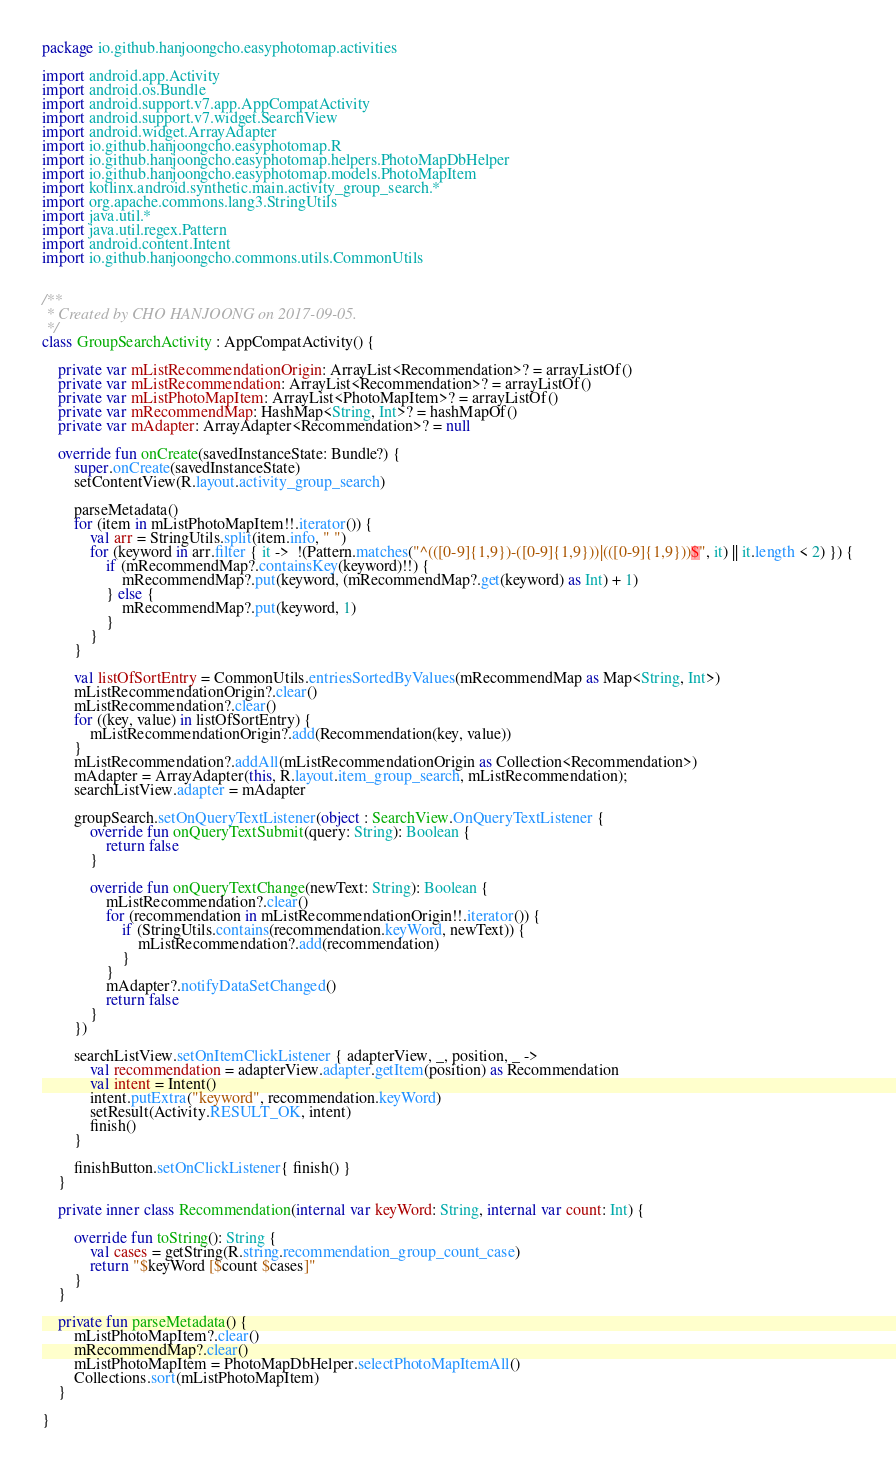<code> <loc_0><loc_0><loc_500><loc_500><_Kotlin_>package io.github.hanjoongcho.easyphotomap.activities

import android.app.Activity
import android.os.Bundle
import android.support.v7.app.AppCompatActivity
import android.support.v7.widget.SearchView
import android.widget.ArrayAdapter
import io.github.hanjoongcho.easyphotomap.R
import io.github.hanjoongcho.easyphotomap.helpers.PhotoMapDbHelper
import io.github.hanjoongcho.easyphotomap.models.PhotoMapItem
import kotlinx.android.synthetic.main.activity_group_search.*
import org.apache.commons.lang3.StringUtils
import java.util.*
import java.util.regex.Pattern
import android.content.Intent
import io.github.hanjoongcho.commons.utils.CommonUtils


/**
 * Created by CHO HANJOONG on 2017-09-05.
 */
class GroupSearchActivity : AppCompatActivity() {

    private var mListRecommendationOrigin: ArrayList<Recommendation>? = arrayListOf()
    private var mListRecommendation: ArrayList<Recommendation>? = arrayListOf()
    private var mListPhotoMapItem: ArrayList<PhotoMapItem>? = arrayListOf()
    private var mRecommendMap: HashMap<String, Int>? = hashMapOf()
    private var mAdapter: ArrayAdapter<Recommendation>? = null

    override fun onCreate(savedInstanceState: Bundle?) {
        super.onCreate(savedInstanceState)
        setContentView(R.layout.activity_group_search)

        parseMetadata()
        for (item in mListPhotoMapItem!!.iterator()) {
            val arr = StringUtils.split(item.info, " ")
            for (keyword in arr.filter { it ->  !(Pattern.matches("^(([0-9]{1,9})-([0-9]{1,9}))|(([0-9]{1,9}))$", it) || it.length < 2) }) {
                if (mRecommendMap?.containsKey(keyword)!!) {
                    mRecommendMap?.put(keyword, (mRecommendMap?.get(keyword) as Int) + 1)
                } else {
                    mRecommendMap?.put(keyword, 1)
                }
            }
        }

        val listOfSortEntry = CommonUtils.entriesSortedByValues(mRecommendMap as Map<String, Int>)
        mListRecommendationOrigin?.clear()
        mListRecommendation?.clear()
        for ((key, value) in listOfSortEntry) {
            mListRecommendationOrigin?.add(Recommendation(key, value))
        }
        mListRecommendation?.addAll(mListRecommendationOrigin as Collection<Recommendation>)
        mAdapter = ArrayAdapter(this, R.layout.item_group_search, mListRecommendation);
        searchListView.adapter = mAdapter

        groupSearch.setOnQueryTextListener(object : SearchView.OnQueryTextListener {
            override fun onQueryTextSubmit(query: String): Boolean {
                return false
            }

            override fun onQueryTextChange(newText: String): Boolean {
                mListRecommendation?.clear()
                for (recommendation in mListRecommendationOrigin!!.iterator()) {
                    if (StringUtils.contains(recommendation.keyWord, newText)) {
                        mListRecommendation?.add(recommendation)
                    }
                }
                mAdapter?.notifyDataSetChanged()
                return false
            }
        })

        searchListView.setOnItemClickListener { adapterView, _, position, _ ->
            val recommendation = adapterView.adapter.getItem(position) as Recommendation
            val intent = Intent()
            intent.putExtra("keyword", recommendation.keyWord)
            setResult(Activity.RESULT_OK, intent)
            finish()
        }

        finishButton.setOnClickListener{ finish() }
    }

    private inner class Recommendation(internal var keyWord: String, internal var count: Int) {

        override fun toString(): String {
            val cases = getString(R.string.recommendation_group_count_case)
            return "$keyWord [$count $cases]"
        }
    }

    private fun parseMetadata() {
        mListPhotoMapItem?.clear()
        mRecommendMap?.clear()
        mListPhotoMapItem = PhotoMapDbHelper.selectPhotoMapItemAll()
        Collections.sort(mListPhotoMapItem)
    }

}</code> 